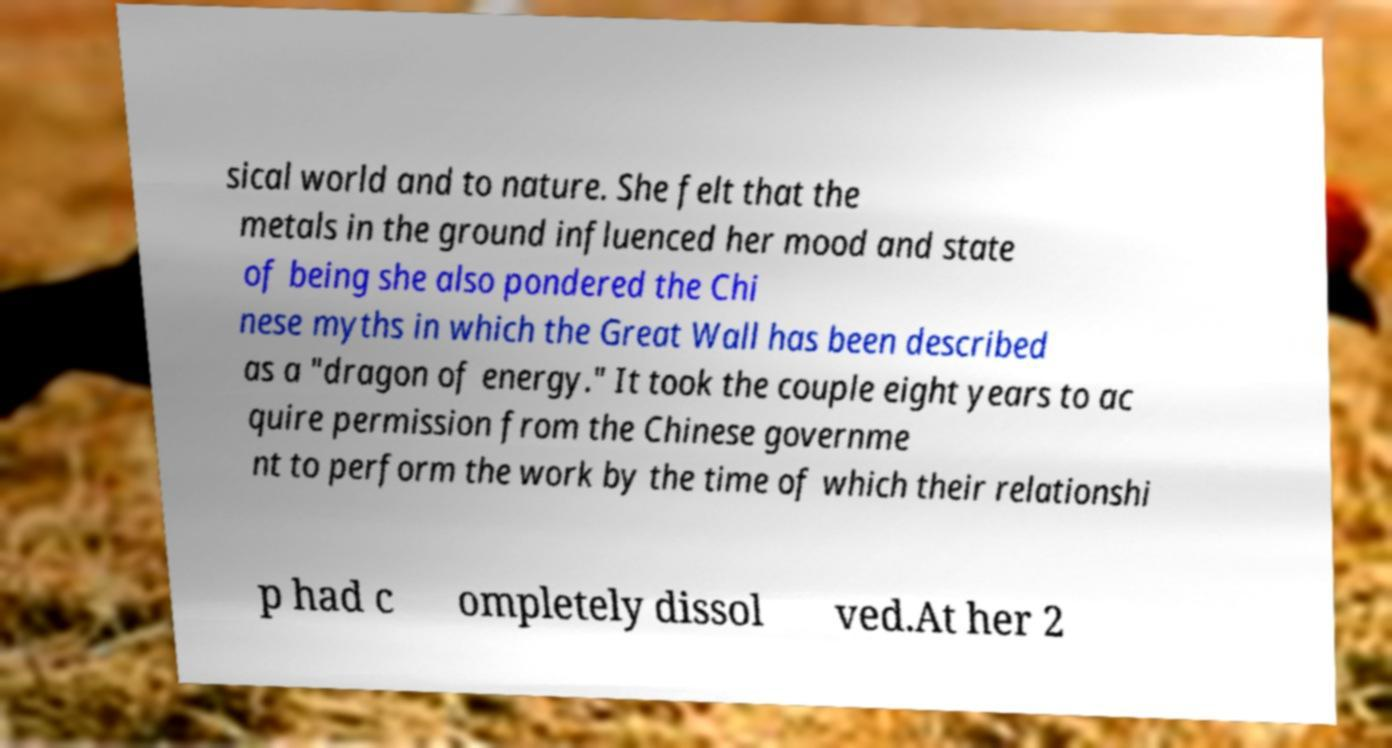Can you read and provide the text displayed in the image?This photo seems to have some interesting text. Can you extract and type it out for me? sical world and to nature. She felt that the metals in the ground influenced her mood and state of being she also pondered the Chi nese myths in which the Great Wall has been described as a "dragon of energy." It took the couple eight years to ac quire permission from the Chinese governme nt to perform the work by the time of which their relationshi p had c ompletely dissol ved.At her 2 